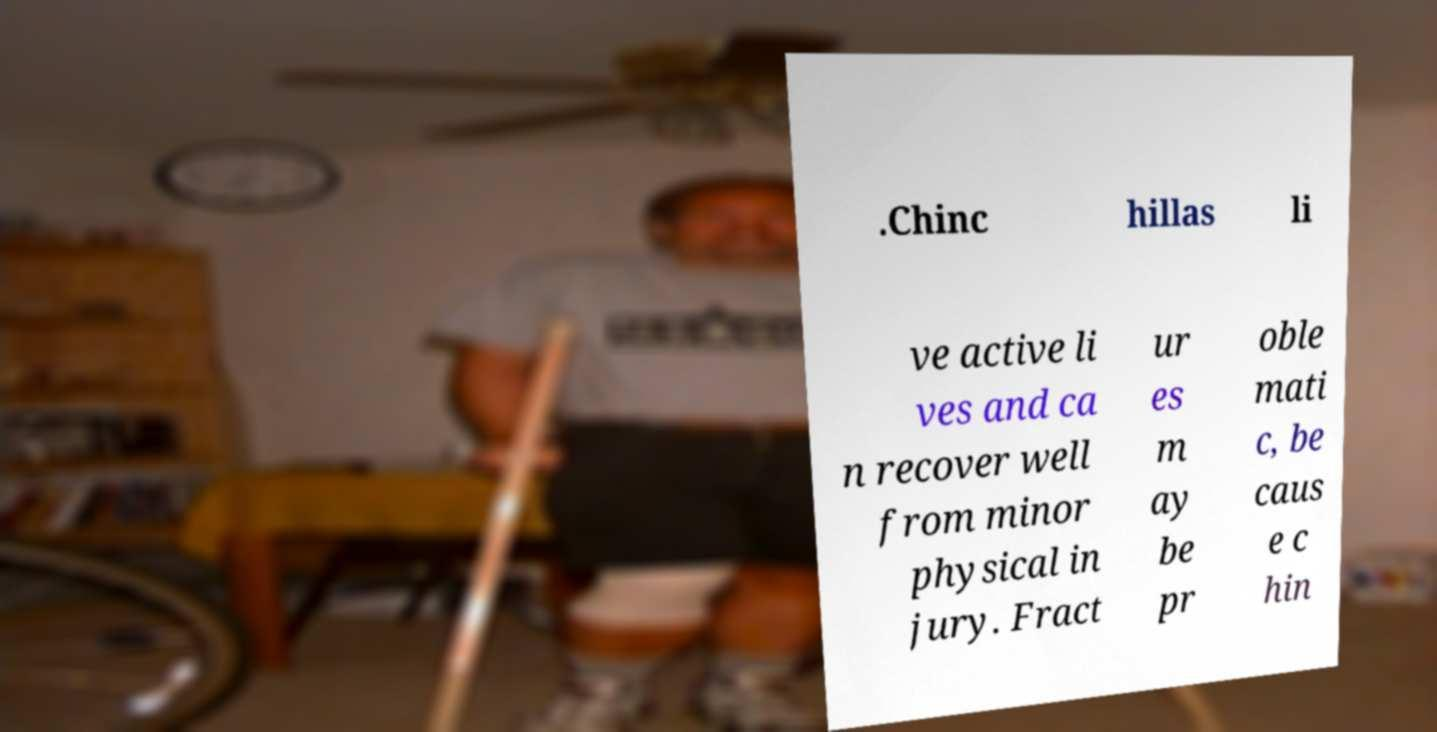There's text embedded in this image that I need extracted. Can you transcribe it verbatim? .Chinc hillas li ve active li ves and ca n recover well from minor physical in jury. Fract ur es m ay be pr oble mati c, be caus e c hin 